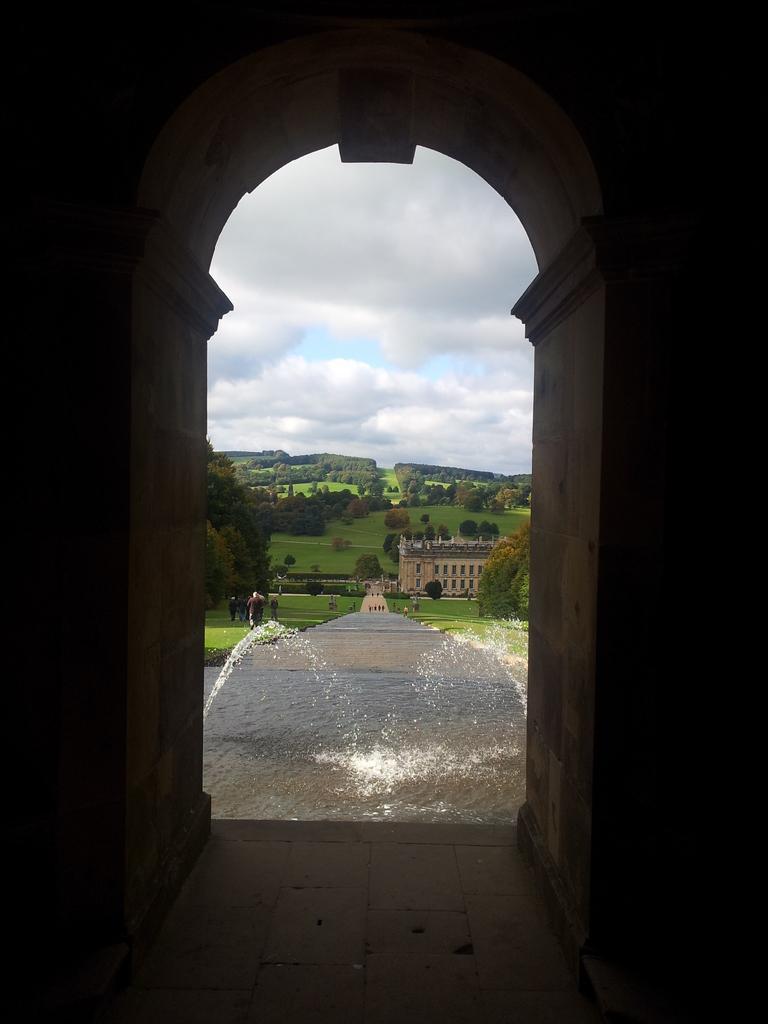Please provide a concise description of this image. In the middle of this image, there is an arch. Through this arch, we can see there is water. On both sides of this water, there are trees and grass on the ground, there are persons, trees, buildings and grass on the ground and there are clouds in the blue sky. 